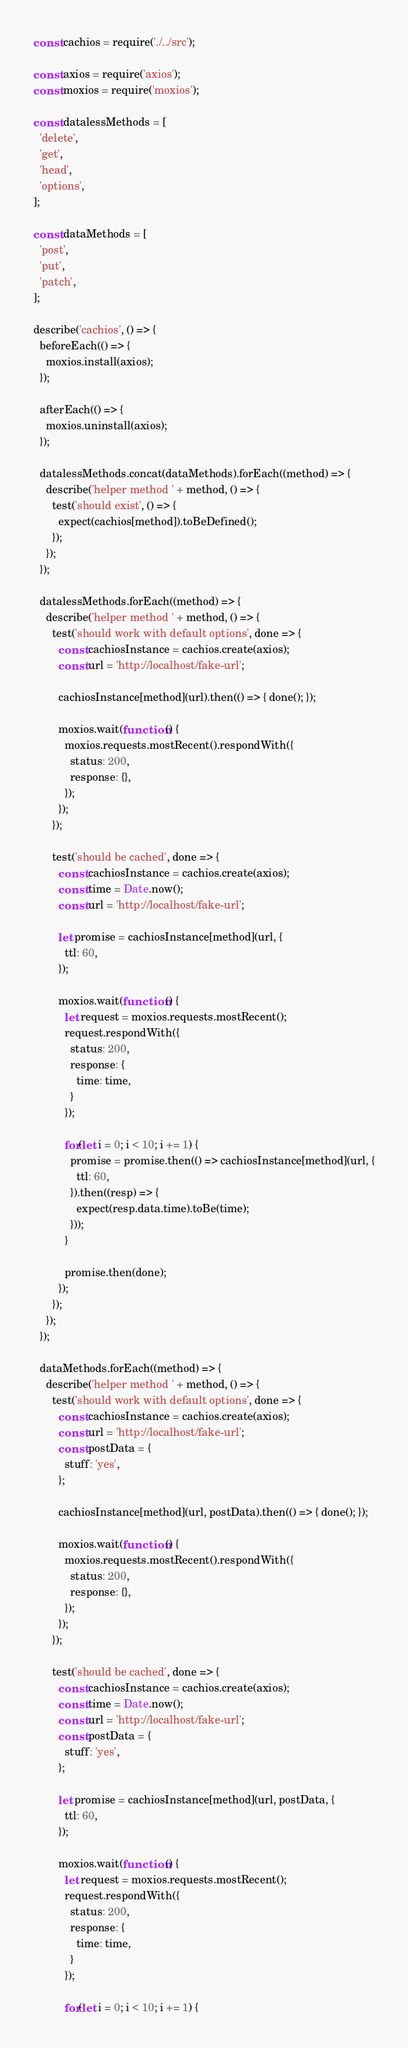Convert code to text. <code><loc_0><loc_0><loc_500><loc_500><_JavaScript_>const cachios = require('./../src');

const axios = require('axios');
const moxios = require('moxios');

const datalessMethods = [
  'delete',
  'get',
  'head',
  'options',
];

const dataMethods = [
  'post',
  'put',
  'patch',
];

describe('cachios', () => {
  beforeEach(() => {
    moxios.install(axios);
  });

  afterEach(() => {
    moxios.uninstall(axios);
  });

  datalessMethods.concat(dataMethods).forEach((method) => {
    describe('helper method ' + method, () => {
      test('should exist', () => {
        expect(cachios[method]).toBeDefined();
      });
    });
  });

  datalessMethods.forEach((method) => {
    describe('helper method ' + method, () => {
      test('should work with default options', done => {
        const cachiosInstance = cachios.create(axios);
        const url = 'http://localhost/fake-url';

        cachiosInstance[method](url).then(() => { done(); });

        moxios.wait(function() {
          moxios.requests.mostRecent().respondWith({
            status: 200,
            response: {},
          });
        });
      });

      test('should be cached', done => {
        const cachiosInstance = cachios.create(axios);
        const time = Date.now();
        const url = 'http://localhost/fake-url';

        let promise = cachiosInstance[method](url, {
          ttl: 60,
        });

        moxios.wait(function() {
          let request = moxios.requests.mostRecent();
          request.respondWith({
            status: 200,
            response: {
              time: time,
            }
          });

          for(let i = 0; i < 10; i += 1) {
            promise = promise.then(() => cachiosInstance[method](url, {
              ttl: 60,
            }).then((resp) => {
              expect(resp.data.time).toBe(time);
            }));
          }

          promise.then(done);
        });
      });
    });
  });

  dataMethods.forEach((method) => {
    describe('helper method ' + method, () => {
      test('should work with default options', done => {
        const cachiosInstance = cachios.create(axios);
        const url = 'http://localhost/fake-url';
        const postData = {
          stuff: 'yes',
        };

        cachiosInstance[method](url, postData).then(() => { done(); });

        moxios.wait(function() {
          moxios.requests.mostRecent().respondWith({
            status: 200,
            response: {},
          });
        });
      });

      test('should be cached', done => {
        const cachiosInstance = cachios.create(axios);
        const time = Date.now();
        const url = 'http://localhost/fake-url';
        const postData = {
          stuff: 'yes',
        };

        let promise = cachiosInstance[method](url, postData, {
          ttl: 60,
        });

        moxios.wait(function() {
          let request = moxios.requests.mostRecent();
          request.respondWith({
            status: 200,
            response: {
              time: time,
            }
          });

          for(let i = 0; i < 10; i += 1) {</code> 